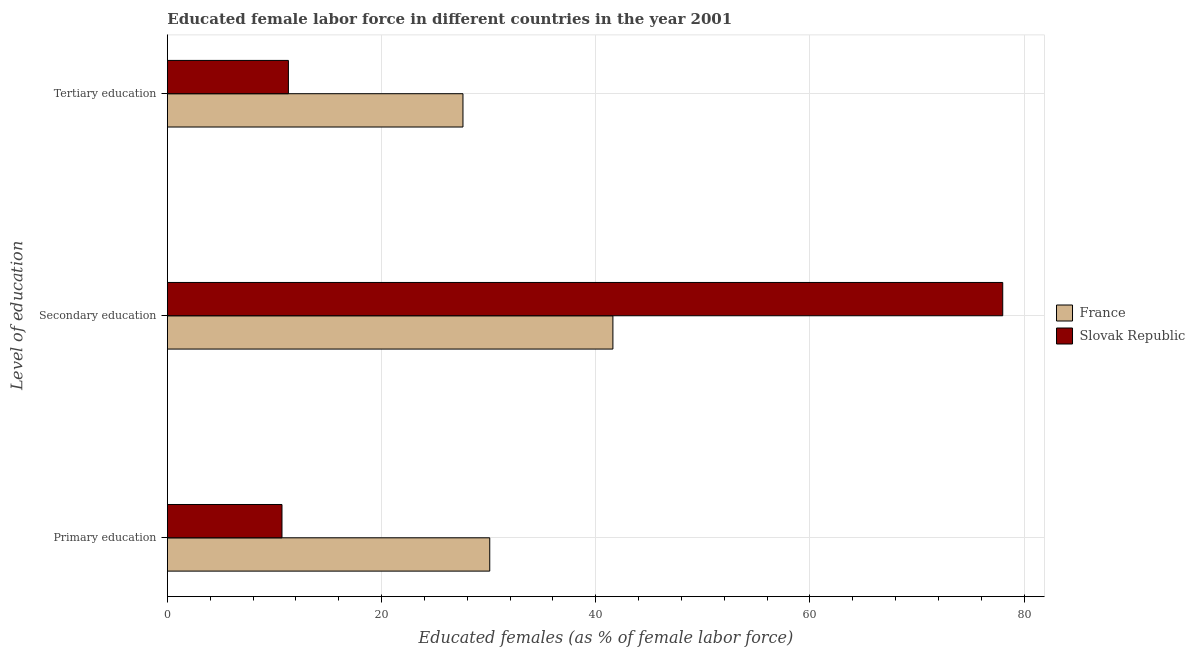How many different coloured bars are there?
Your answer should be compact. 2. Are the number of bars per tick equal to the number of legend labels?
Provide a succinct answer. Yes. How many bars are there on the 3rd tick from the bottom?
Give a very brief answer. 2. What is the label of the 2nd group of bars from the top?
Provide a short and direct response. Secondary education. What is the percentage of female labor force who received tertiary education in Slovak Republic?
Give a very brief answer. 11.3. Across all countries, what is the maximum percentage of female labor force who received primary education?
Offer a very short reply. 30.1. Across all countries, what is the minimum percentage of female labor force who received tertiary education?
Your answer should be compact. 11.3. In which country was the percentage of female labor force who received secondary education maximum?
Your response must be concise. Slovak Republic. In which country was the percentage of female labor force who received primary education minimum?
Ensure brevity in your answer.  Slovak Republic. What is the total percentage of female labor force who received secondary education in the graph?
Your answer should be compact. 119.6. What is the difference between the percentage of female labor force who received primary education in Slovak Republic and that in France?
Your answer should be compact. -19.4. What is the difference between the percentage of female labor force who received tertiary education in Slovak Republic and the percentage of female labor force who received primary education in France?
Provide a short and direct response. -18.8. What is the average percentage of female labor force who received secondary education per country?
Keep it short and to the point. 59.8. What is the difference between the percentage of female labor force who received tertiary education and percentage of female labor force who received primary education in France?
Your response must be concise. -2.5. What is the ratio of the percentage of female labor force who received primary education in France to that in Slovak Republic?
Offer a very short reply. 2.81. Is the percentage of female labor force who received primary education in France less than that in Slovak Republic?
Your answer should be very brief. No. What is the difference between the highest and the second highest percentage of female labor force who received tertiary education?
Ensure brevity in your answer.  16.3. What is the difference between the highest and the lowest percentage of female labor force who received primary education?
Your response must be concise. 19.4. In how many countries, is the percentage of female labor force who received primary education greater than the average percentage of female labor force who received primary education taken over all countries?
Your answer should be compact. 1. Is the sum of the percentage of female labor force who received primary education in France and Slovak Republic greater than the maximum percentage of female labor force who received tertiary education across all countries?
Make the answer very short. Yes. What does the 1st bar from the bottom in Tertiary education represents?
Provide a short and direct response. France. Are all the bars in the graph horizontal?
Offer a terse response. Yes. How many countries are there in the graph?
Offer a terse response. 2. Does the graph contain any zero values?
Provide a succinct answer. No. Does the graph contain grids?
Keep it short and to the point. Yes. How many legend labels are there?
Offer a very short reply. 2. What is the title of the graph?
Ensure brevity in your answer.  Educated female labor force in different countries in the year 2001. Does "Greece" appear as one of the legend labels in the graph?
Make the answer very short. No. What is the label or title of the X-axis?
Ensure brevity in your answer.  Educated females (as % of female labor force). What is the label or title of the Y-axis?
Offer a terse response. Level of education. What is the Educated females (as % of female labor force) in France in Primary education?
Provide a succinct answer. 30.1. What is the Educated females (as % of female labor force) of Slovak Republic in Primary education?
Provide a short and direct response. 10.7. What is the Educated females (as % of female labor force) of France in Secondary education?
Ensure brevity in your answer.  41.6. What is the Educated females (as % of female labor force) in Slovak Republic in Secondary education?
Ensure brevity in your answer.  78. What is the Educated females (as % of female labor force) of France in Tertiary education?
Offer a terse response. 27.6. What is the Educated females (as % of female labor force) of Slovak Republic in Tertiary education?
Ensure brevity in your answer.  11.3. Across all Level of education, what is the maximum Educated females (as % of female labor force) of France?
Make the answer very short. 41.6. Across all Level of education, what is the maximum Educated females (as % of female labor force) in Slovak Republic?
Offer a very short reply. 78. Across all Level of education, what is the minimum Educated females (as % of female labor force) in France?
Offer a terse response. 27.6. Across all Level of education, what is the minimum Educated females (as % of female labor force) of Slovak Republic?
Keep it short and to the point. 10.7. What is the total Educated females (as % of female labor force) in France in the graph?
Give a very brief answer. 99.3. What is the total Educated females (as % of female labor force) of Slovak Republic in the graph?
Your answer should be compact. 100. What is the difference between the Educated females (as % of female labor force) of Slovak Republic in Primary education and that in Secondary education?
Give a very brief answer. -67.3. What is the difference between the Educated females (as % of female labor force) in Slovak Republic in Primary education and that in Tertiary education?
Provide a succinct answer. -0.6. What is the difference between the Educated females (as % of female labor force) in France in Secondary education and that in Tertiary education?
Provide a succinct answer. 14. What is the difference between the Educated females (as % of female labor force) of Slovak Republic in Secondary education and that in Tertiary education?
Offer a very short reply. 66.7. What is the difference between the Educated females (as % of female labor force) in France in Primary education and the Educated females (as % of female labor force) in Slovak Republic in Secondary education?
Your answer should be compact. -47.9. What is the difference between the Educated females (as % of female labor force) in France in Primary education and the Educated females (as % of female labor force) in Slovak Republic in Tertiary education?
Your response must be concise. 18.8. What is the difference between the Educated females (as % of female labor force) of France in Secondary education and the Educated females (as % of female labor force) of Slovak Republic in Tertiary education?
Offer a very short reply. 30.3. What is the average Educated females (as % of female labor force) of France per Level of education?
Provide a short and direct response. 33.1. What is the average Educated females (as % of female labor force) in Slovak Republic per Level of education?
Provide a succinct answer. 33.33. What is the difference between the Educated females (as % of female labor force) of France and Educated females (as % of female labor force) of Slovak Republic in Primary education?
Provide a short and direct response. 19.4. What is the difference between the Educated females (as % of female labor force) of France and Educated females (as % of female labor force) of Slovak Republic in Secondary education?
Offer a terse response. -36.4. What is the difference between the Educated females (as % of female labor force) of France and Educated females (as % of female labor force) of Slovak Republic in Tertiary education?
Your answer should be very brief. 16.3. What is the ratio of the Educated females (as % of female labor force) of France in Primary education to that in Secondary education?
Provide a succinct answer. 0.72. What is the ratio of the Educated females (as % of female labor force) of Slovak Republic in Primary education to that in Secondary education?
Give a very brief answer. 0.14. What is the ratio of the Educated females (as % of female labor force) in France in Primary education to that in Tertiary education?
Offer a very short reply. 1.09. What is the ratio of the Educated females (as % of female labor force) in Slovak Republic in Primary education to that in Tertiary education?
Make the answer very short. 0.95. What is the ratio of the Educated females (as % of female labor force) in France in Secondary education to that in Tertiary education?
Ensure brevity in your answer.  1.51. What is the ratio of the Educated females (as % of female labor force) in Slovak Republic in Secondary education to that in Tertiary education?
Make the answer very short. 6.9. What is the difference between the highest and the second highest Educated females (as % of female labor force) of Slovak Republic?
Provide a short and direct response. 66.7. What is the difference between the highest and the lowest Educated females (as % of female labor force) in France?
Keep it short and to the point. 14. What is the difference between the highest and the lowest Educated females (as % of female labor force) in Slovak Republic?
Keep it short and to the point. 67.3. 